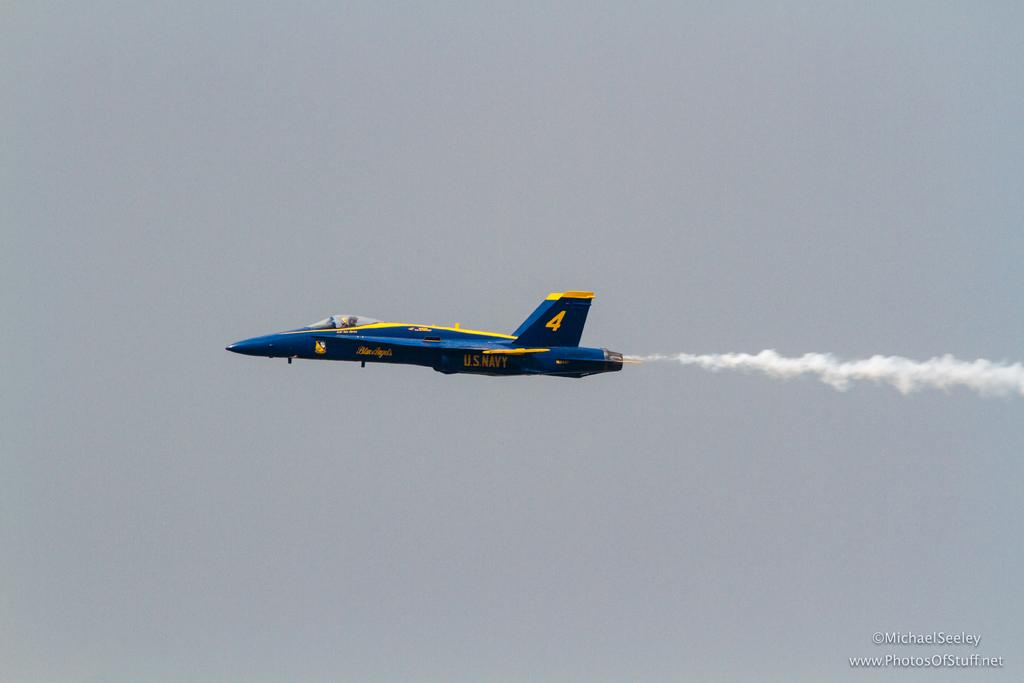What is the main subject of the image? The main subject of the image is an aircraft. What colors are used to paint the aircraft? The aircraft is blue and yellow in color. What can be seen behind the aircraft in the image? There is smoke visible behind the aircraft. What is visible in the background of the image? The sky is visible in the background of the image. What arithmetic problem is being solved by the aircraft in the image? There is no arithmetic problem being solved by the aircraft in the image; it is simply an aircraft flying through the sky. 